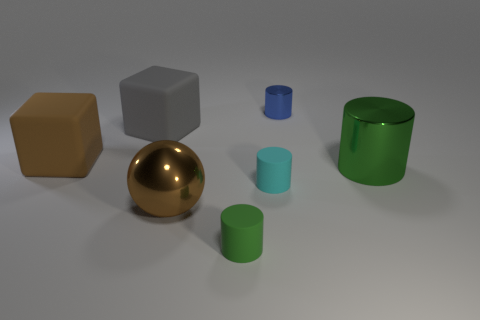Subtract all small green rubber cylinders. How many cylinders are left? 3 Add 2 small objects. How many objects exist? 9 Subtract 1 cubes. How many cubes are left? 1 Subtract all gray blocks. How many blocks are left? 1 Add 2 small gray metallic blocks. How many small gray metallic blocks exist? 2 Subtract 0 blue cubes. How many objects are left? 7 Subtract all spheres. How many objects are left? 6 Subtract all cyan cubes. Subtract all purple cylinders. How many cubes are left? 2 Subtract all red cylinders. How many gray blocks are left? 1 Subtract all tiny shiny things. Subtract all shiny objects. How many objects are left? 3 